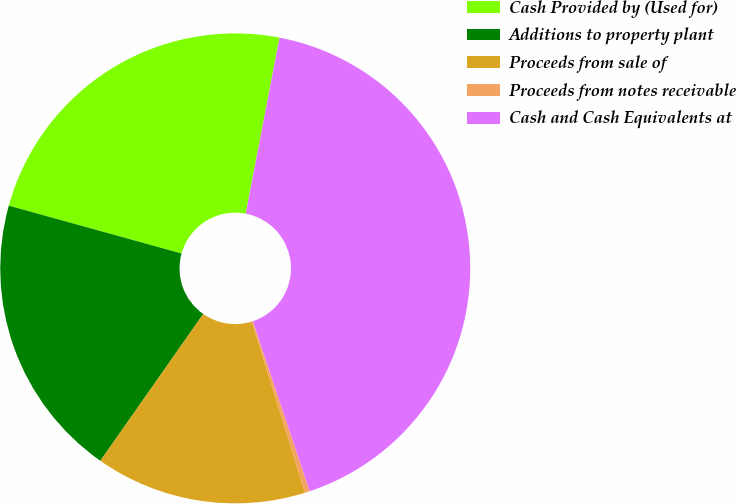<chart> <loc_0><loc_0><loc_500><loc_500><pie_chart><fcel>Cash Provided by (Used for)<fcel>Additions to property plant<fcel>Proceeds from sale of<fcel>Proceeds from notes receivable<fcel>Cash and Cash Equivalents at<nl><fcel>23.72%<fcel>19.57%<fcel>14.53%<fcel>0.33%<fcel>41.85%<nl></chart> 